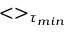<formula> <loc_0><loc_0><loc_500><loc_500>< > _ { \tau _ { \min } }</formula> 